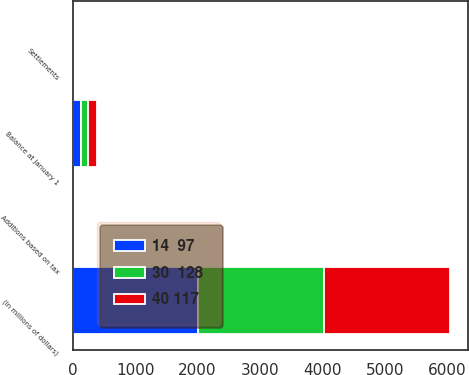Convert chart to OTSL. <chart><loc_0><loc_0><loc_500><loc_500><stacked_bar_chart><ecel><fcel>(In millions of dollars)<fcel>Balance at January 1<fcel>Additions based on tax<fcel>Settlements<nl><fcel>14  97<fcel>2014<fcel>128<fcel>13<fcel>4<nl><fcel>30  128<fcel>2013<fcel>117<fcel>16<fcel>3<nl><fcel>40 117<fcel>2012<fcel>143<fcel>26<fcel>6<nl></chart> 